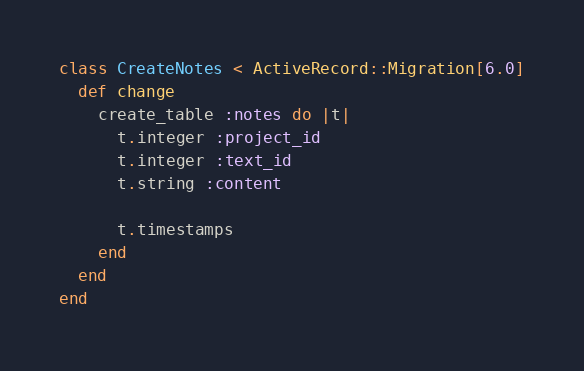Convert code to text. <code><loc_0><loc_0><loc_500><loc_500><_Ruby_>class CreateNotes < ActiveRecord::Migration[6.0]
  def change
    create_table :notes do |t|
      t.integer :project_id
      t.integer :text_id
      t.string :content

      t.timestamps
    end
  end
end
</code> 